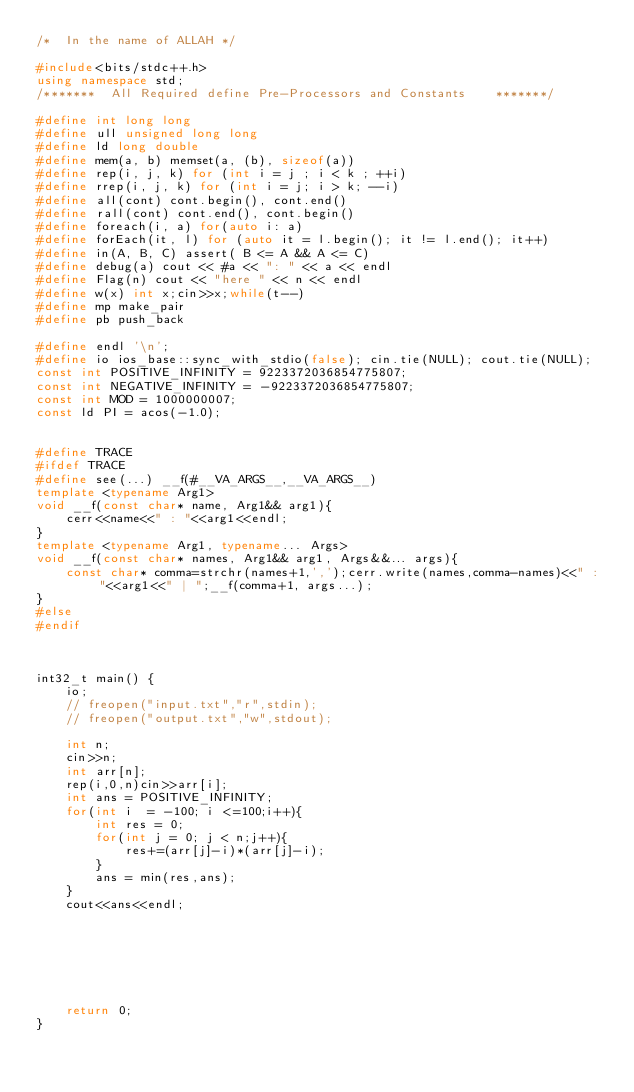Convert code to text. <code><loc_0><loc_0><loc_500><loc_500><_C++_>/*  In the name of ALLAH */

#include<bits/stdc++.h>
using namespace std;
/*******  All Required define Pre-Processors and Constants    *******/

#define int long long
#define ull unsigned long long 
#define ld long double
#define mem(a, b) memset(a, (b), sizeof(a))
#define rep(i, j, k) for (int i = j ; i < k ; ++i)
#define rrep(i, j, k) for (int i = j; i > k; --i)
#define all(cont) cont.begin(), cont.end()
#define rall(cont) cont.end(), cont.begin()
#define foreach(i, a) for(auto i: a)
#define forEach(it, l) for (auto it = l.begin(); it != l.end(); it++)
#define in(A, B, C) assert( B <= A && A <= C)
#define debug(a) cout << #a << ": " << a << endl
#define Flag(n) cout << "here " << n << endl
#define w(x) int x;cin>>x;while(t--)
#define mp make_pair
#define pb push_back

#define endl '\n';
#define io ios_base::sync_with_stdio(false); cin.tie(NULL); cout.tie(NULL);
const int POSITIVE_INFINITY = 9223372036854775807;
const int NEGATIVE_INFINITY = -9223372036854775807;
const int MOD = 1000000007;
const ld PI = acos(-1.0);
 

#define TRACE
#ifdef TRACE
#define see(...) __f(#__VA_ARGS__,__VA_ARGS__)
template <typename Arg1>
void __f(const char* name, Arg1&& arg1){
    cerr<<name<<" : "<<arg1<<endl;
}
template <typename Arg1, typename... Args>
void __f(const char* names, Arg1&& arg1, Args&&... args){
    const char* comma=strchr(names+1,',');cerr.write(names,comma-names)<<" : "<<arg1<<" | ";__f(comma+1, args...);
}
#else
#endif



int32_t main() {
    io;
    // freopen("input.txt","r",stdin); 
    // freopen("output.txt","w",stdout);
    
    int n;
    cin>>n;
    int arr[n];
    rep(i,0,n)cin>>arr[i];
    int ans = POSITIVE_INFINITY;
    for(int i  = -100; i <=100;i++){
        int res = 0;
        for(int j = 0; j < n;j++){
            res+=(arr[j]-i)*(arr[j]-i);
        }
        ans = min(res,ans);
    }
    cout<<ans<<endl;


 

 
    
 
    return 0;
}
</code> 